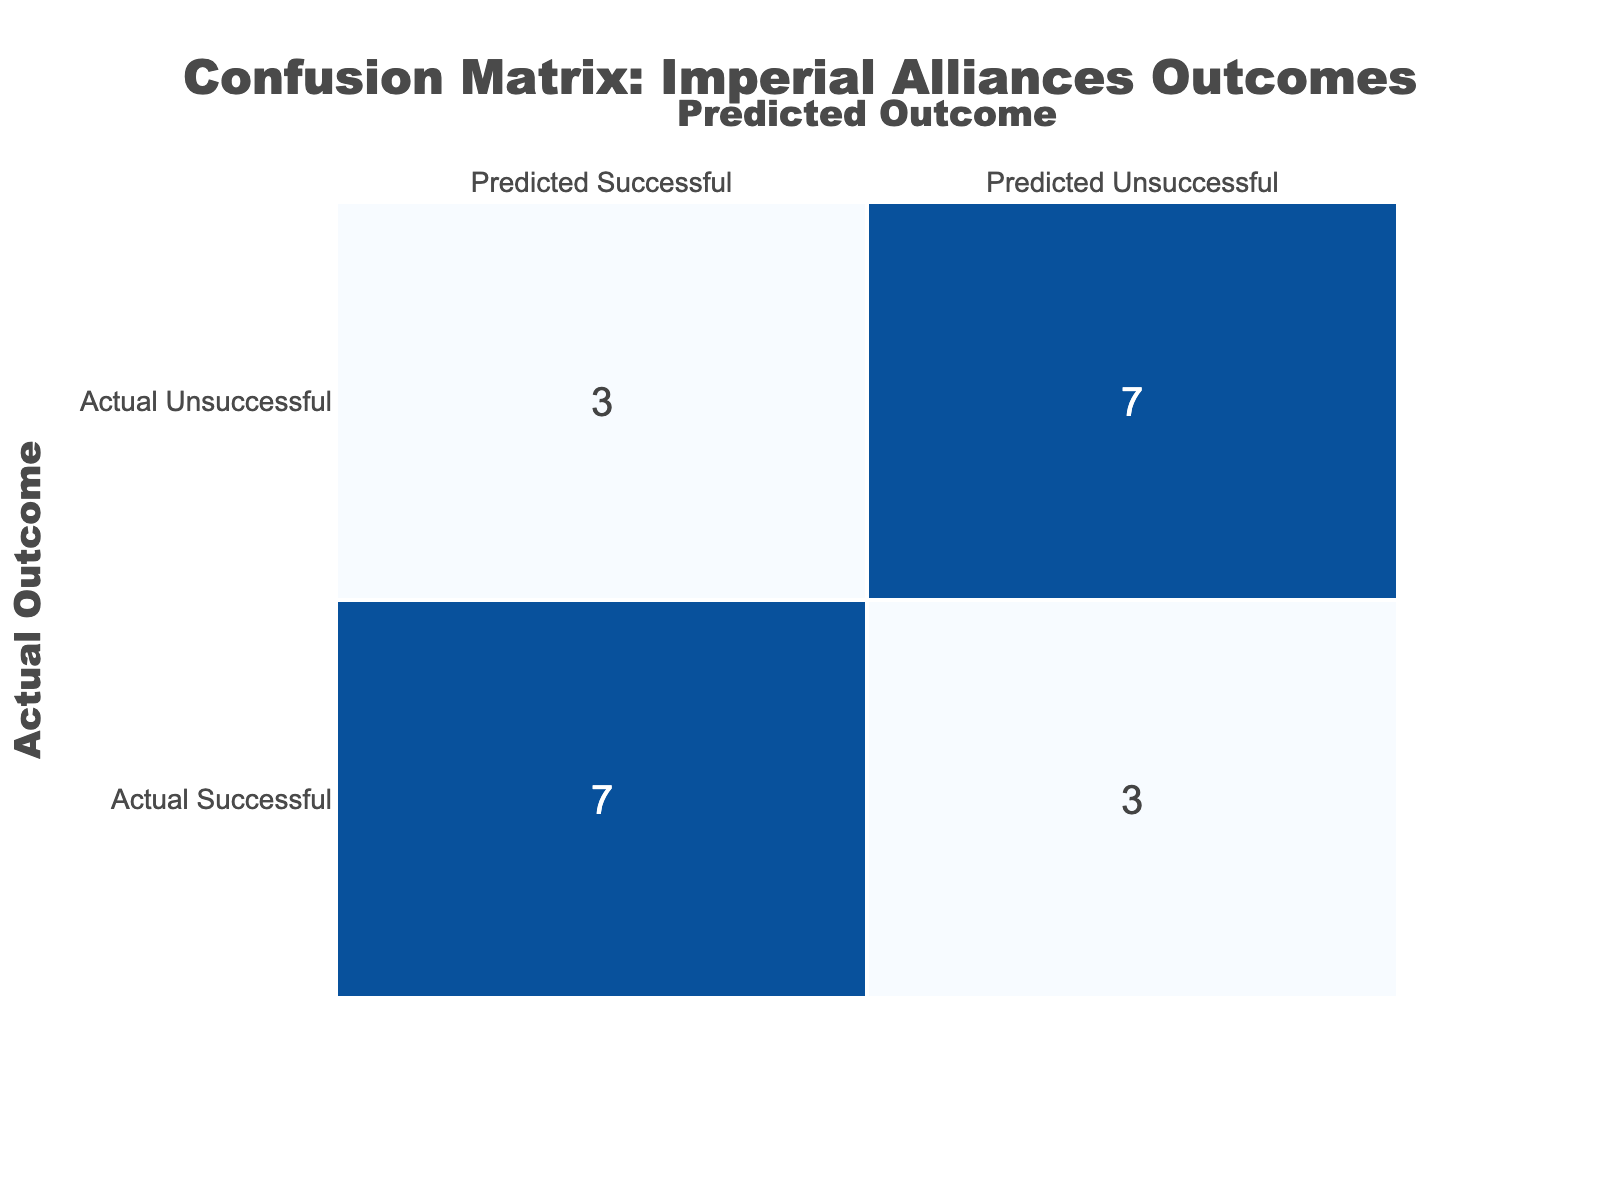What is the total number of successful alliances formed during the imperial expansions listed in the table? The table lists alliances with their outcomes. To find the total number of successful alliances, we can sum up the 'Successful' column, which contains five instances (British Empire - Qing Dynasty, French Empire - Vietnam, Spanish Empire - Incan Empire, Portuguese Empire - Kingdom of Kongo, Japanese Empire - Korea, and Belgian Empire - Congo Free State). Therefore, the total is 6.
Answer: 6 Which alliance had an unsuccessful outcome during imperial expansion? By looking at the 'Unsuccessful' column, we can identify the alliances that had a value of 1. The alliances that are listed as having an unsuccessful outcome are: German Empire - Ottoman Empire and Italian Empire - Ethiopia. Thus, these two alliances had unsuccessful outcomes.
Answer: German Empire - Ottoman Empire, Italian Empire - Ethiopia What percentage of alliances were successfully formed? There are 10 total alliances. The number of successful alliances is 6. To find the percentage, we will use the formula (number of successful alliances / total alliances) * 100. That is (6/10) * 100 which gives us 60%.
Answer: 60% Did any alliance have a neutral outcome listed in the table? We look at the 'Outcome' column for any instances marked as N/A. There is one such case which is the alliance of the Russian Empire - Alaska. Hence, we confirm that there was one neutral outcome.
Answer: Yes How many alliances resulted in colonization? To find this, we can filter the table for the 'Outcome' column. The outcomes that resulted in colonization are noted under French Empire - Vietnam and Dutch Empire - Indonesia. This results in a total of 2 alliances that were specifically for colonization.
Answer: 2 What alliances resulted in successful outcomes compared to unsuccessful outcomes? From the data, we can see that there are 6 successful outcomes and 3 unsuccessful outcomes. This leads us to calculate the difference, which results in a successful completion of 3 more alliances than those that were unsuccessful.
Answer: Successful: 6, Unsuccessful: 3, Difference: 3 Which outcomes had more successful than unsuccessful alliances? By checking the outcomes from the table, we find that the following alliances had successful outcomes: British Empire - Qing Dynasty, French Empire - Vietnam, Spanish Empire - Incan Empire, Portuguese Empire - Kingdom of Kongo, Japanese Empire - Korea, and Belgian Empire - Congo Free State. All of these resulted in successes compared to the 2 unsuccessful (German Empire - Ottoman Empire and Italian Empire - Ethiopia). Since there are more successful outcomes represented here, we can confirm that most alliances were successful.
Answer: Yes What is the ratio of successful to unsuccessful alliances? We identified that there are 6 successful alliances and 3 unsuccessful alliances from the table. Thus, to find the ratio, we express it as 6:3. This can be simplified to 2:1.
Answer: 2:1 